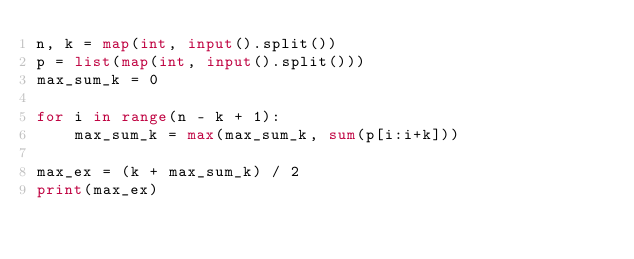Convert code to text. <code><loc_0><loc_0><loc_500><loc_500><_Python_>n, k = map(int, input().split())
p = list(map(int, input().split()))
max_sum_k = 0

for i in range(n - k + 1):
    max_sum_k = max(max_sum_k, sum(p[i:i+k]))

max_ex = (k + max_sum_k) / 2
print(max_ex)
</code> 